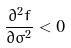<formula> <loc_0><loc_0><loc_500><loc_500>\frac { \partial ^ { 2 } f } { \partial \sigma ^ { 2 } } < 0</formula> 